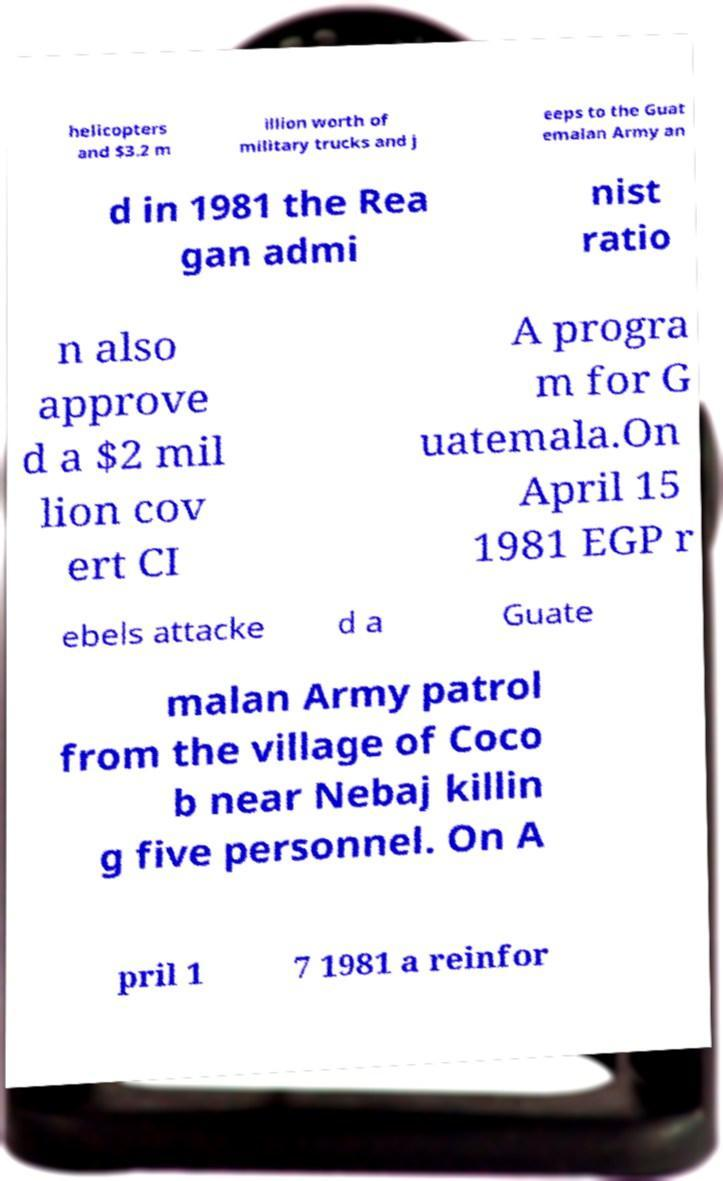Can you accurately transcribe the text from the provided image for me? helicopters and $3.2 m illion worth of military trucks and j eeps to the Guat emalan Army an d in 1981 the Rea gan admi nist ratio n also approve d a $2 mil lion cov ert CI A progra m for G uatemala.On April 15 1981 EGP r ebels attacke d a Guate malan Army patrol from the village of Coco b near Nebaj killin g five personnel. On A pril 1 7 1981 a reinfor 